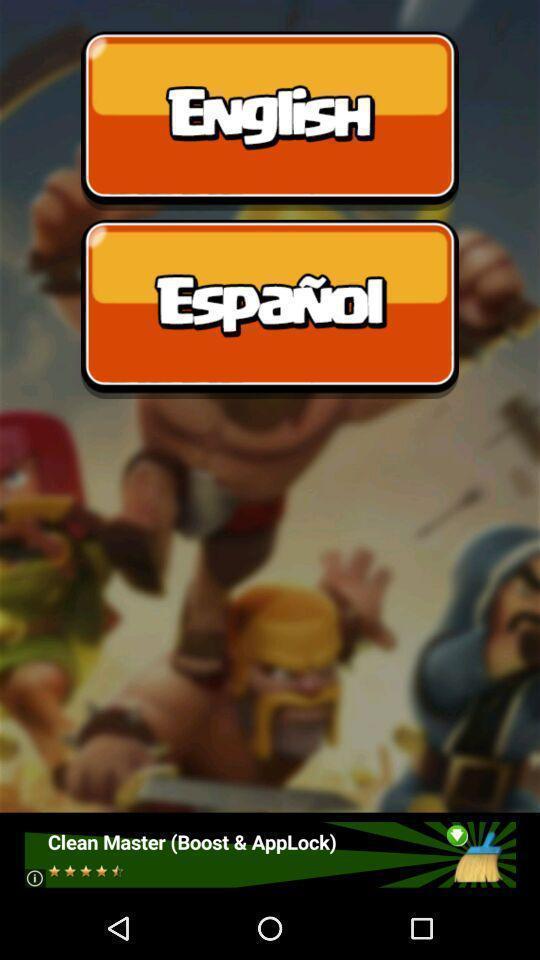Describe the content in this image. Screen displaying different language options. 